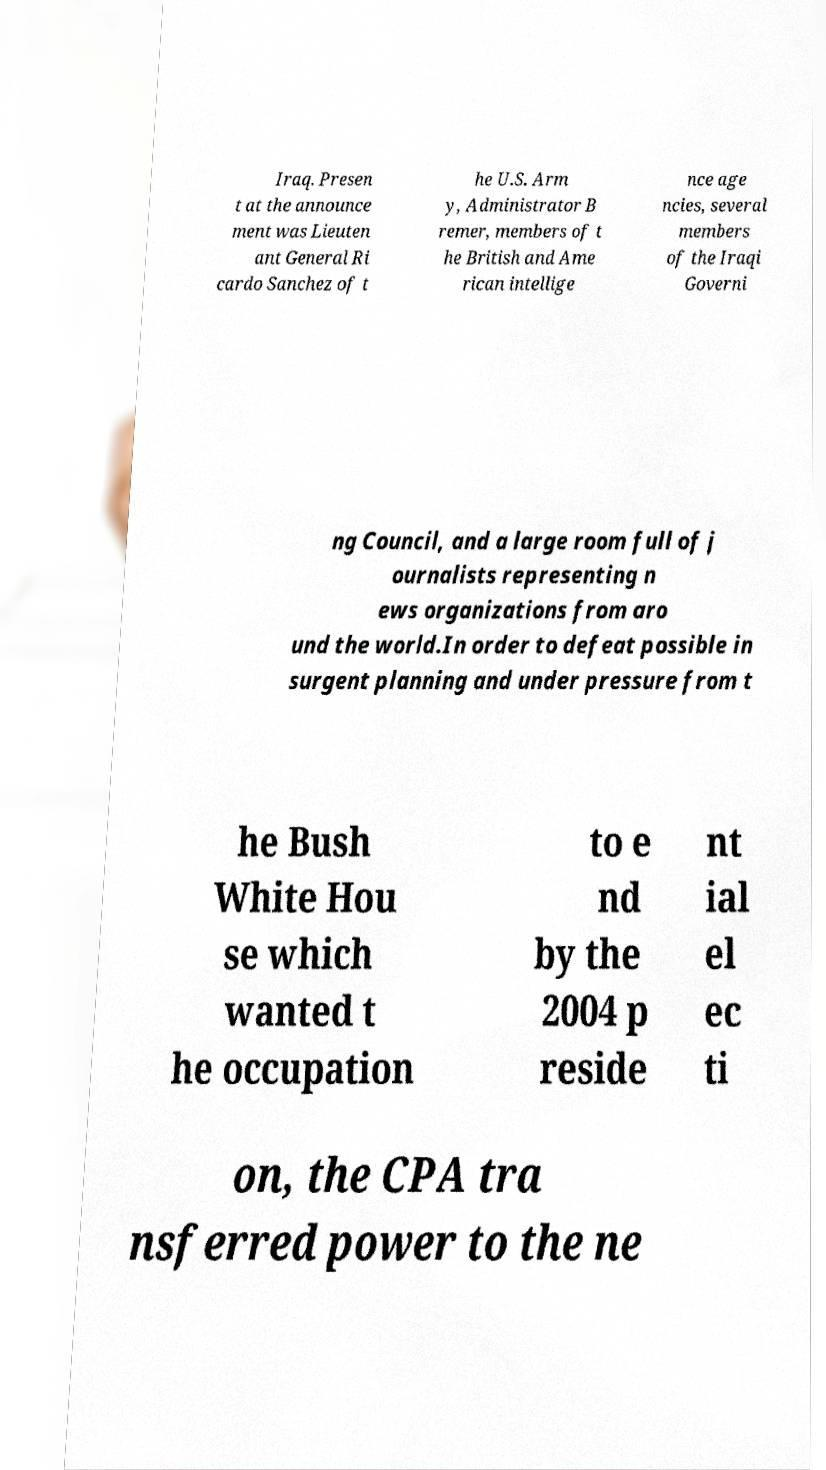Could you extract and type out the text from this image? Iraq. Presen t at the announce ment was Lieuten ant General Ri cardo Sanchez of t he U.S. Arm y, Administrator B remer, members of t he British and Ame rican intellige nce age ncies, several members of the Iraqi Governi ng Council, and a large room full of j ournalists representing n ews organizations from aro und the world.In order to defeat possible in surgent planning and under pressure from t he Bush White Hou se which wanted t he occupation to e nd by the 2004 p reside nt ial el ec ti on, the CPA tra nsferred power to the ne 